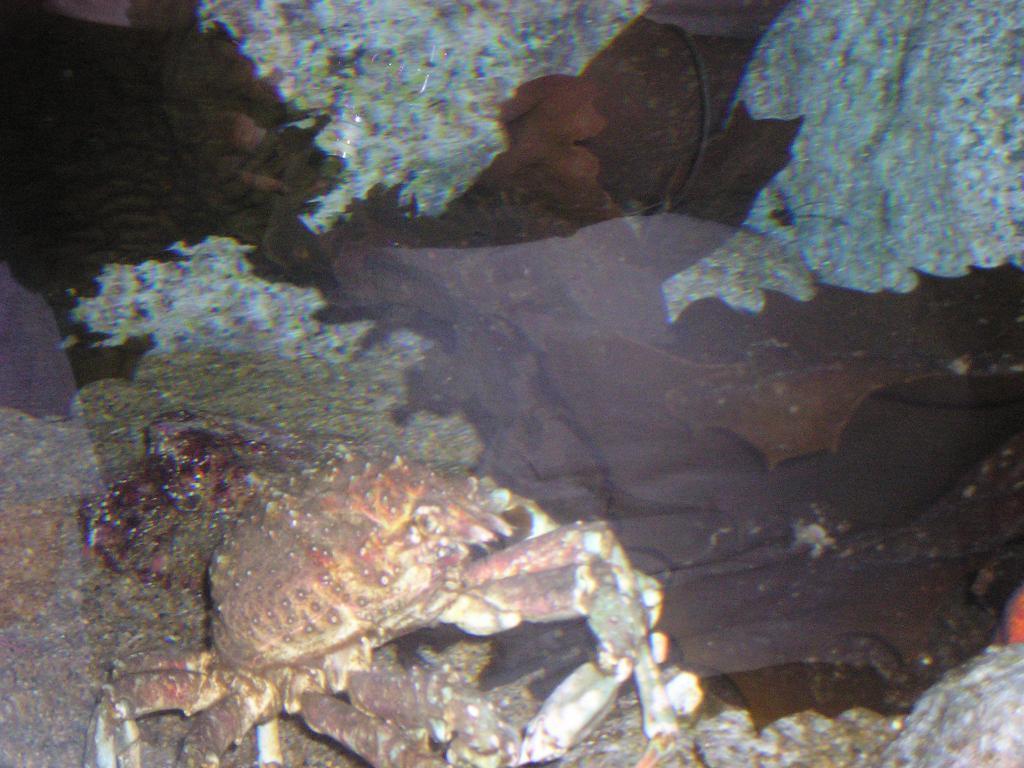Could you give a brief overview of what you see in this image? In this image we can see the crab in the water. 